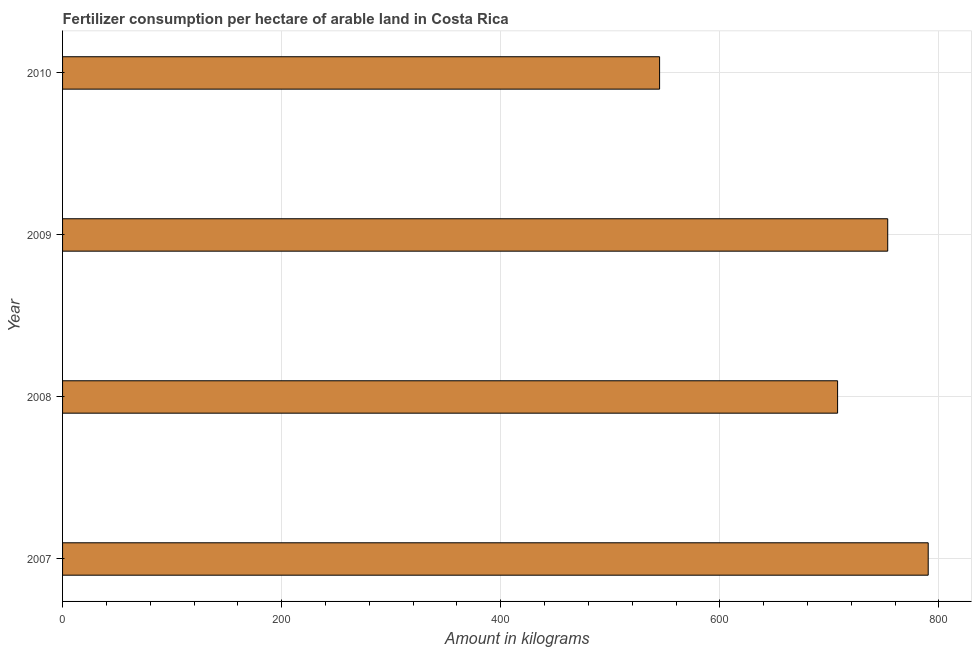Does the graph contain any zero values?
Your response must be concise. No. Does the graph contain grids?
Make the answer very short. Yes. What is the title of the graph?
Your response must be concise. Fertilizer consumption per hectare of arable land in Costa Rica . What is the label or title of the X-axis?
Give a very brief answer. Amount in kilograms. What is the label or title of the Y-axis?
Your answer should be compact. Year. What is the amount of fertilizer consumption in 2010?
Offer a very short reply. 544.99. Across all years, what is the maximum amount of fertilizer consumption?
Offer a terse response. 790.2. Across all years, what is the minimum amount of fertilizer consumption?
Your answer should be compact. 544.99. What is the sum of the amount of fertilizer consumption?
Your answer should be very brief. 2795.9. What is the difference between the amount of fertilizer consumption in 2009 and 2010?
Offer a terse response. 208.25. What is the average amount of fertilizer consumption per year?
Your answer should be very brief. 698.98. What is the median amount of fertilizer consumption?
Offer a terse response. 730.36. Do a majority of the years between 2009 and 2007 (inclusive) have amount of fertilizer consumption greater than 600 kg?
Your answer should be very brief. Yes. What is the ratio of the amount of fertilizer consumption in 2009 to that in 2010?
Provide a short and direct response. 1.38. Is the amount of fertilizer consumption in 2009 less than that in 2010?
Provide a succinct answer. No. What is the difference between the highest and the second highest amount of fertilizer consumption?
Your response must be concise. 36.96. Is the sum of the amount of fertilizer consumption in 2008 and 2010 greater than the maximum amount of fertilizer consumption across all years?
Offer a terse response. Yes. What is the difference between the highest and the lowest amount of fertilizer consumption?
Your response must be concise. 245.2. Are all the bars in the graph horizontal?
Your response must be concise. Yes. How many years are there in the graph?
Make the answer very short. 4. What is the difference between two consecutive major ticks on the X-axis?
Offer a very short reply. 200. What is the Amount in kilograms in 2007?
Give a very brief answer. 790.2. What is the Amount in kilograms in 2008?
Your response must be concise. 707.48. What is the Amount in kilograms of 2009?
Offer a very short reply. 753.24. What is the Amount in kilograms in 2010?
Offer a very short reply. 544.99. What is the difference between the Amount in kilograms in 2007 and 2008?
Provide a succinct answer. 82.72. What is the difference between the Amount in kilograms in 2007 and 2009?
Your answer should be very brief. 36.96. What is the difference between the Amount in kilograms in 2007 and 2010?
Your answer should be compact. 245.2. What is the difference between the Amount in kilograms in 2008 and 2009?
Your answer should be compact. -45.76. What is the difference between the Amount in kilograms in 2008 and 2010?
Your answer should be very brief. 162.49. What is the difference between the Amount in kilograms in 2009 and 2010?
Ensure brevity in your answer.  208.25. What is the ratio of the Amount in kilograms in 2007 to that in 2008?
Your response must be concise. 1.12. What is the ratio of the Amount in kilograms in 2007 to that in 2009?
Your response must be concise. 1.05. What is the ratio of the Amount in kilograms in 2007 to that in 2010?
Ensure brevity in your answer.  1.45. What is the ratio of the Amount in kilograms in 2008 to that in 2009?
Your response must be concise. 0.94. What is the ratio of the Amount in kilograms in 2008 to that in 2010?
Provide a short and direct response. 1.3. What is the ratio of the Amount in kilograms in 2009 to that in 2010?
Provide a short and direct response. 1.38. 